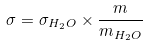<formula> <loc_0><loc_0><loc_500><loc_500>\sigma = \sigma _ { H _ { 2 } O } \times \frac { m } { m _ { H _ { 2 } O } }</formula> 